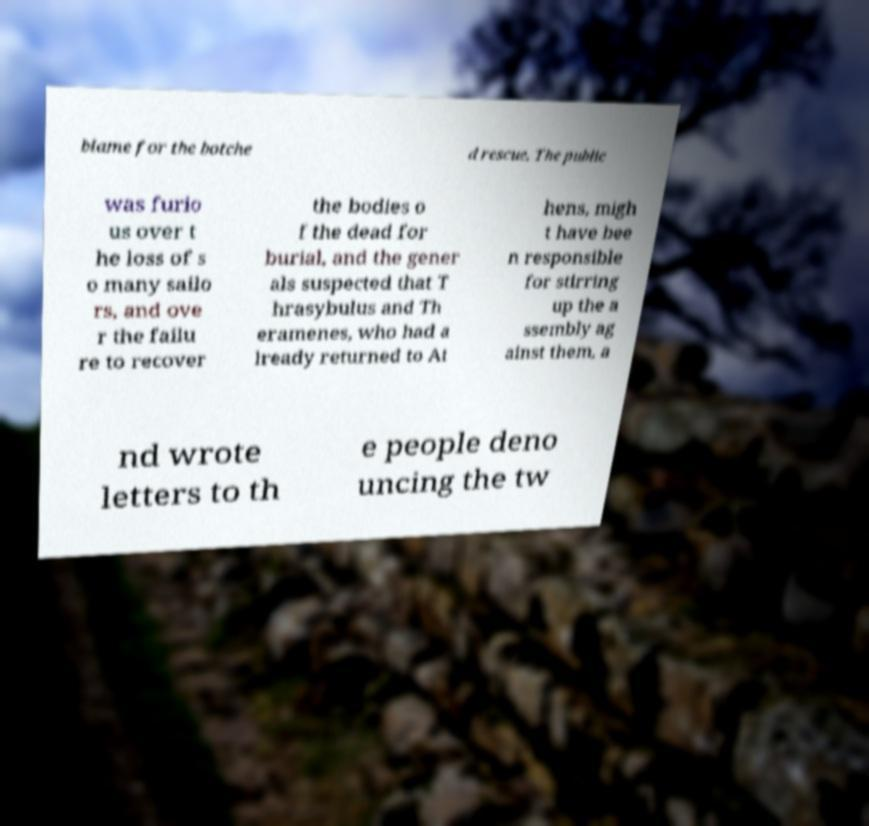There's text embedded in this image that I need extracted. Can you transcribe it verbatim? blame for the botche d rescue. The public was furio us over t he loss of s o many sailo rs, and ove r the failu re to recover the bodies o f the dead for burial, and the gener als suspected that T hrasybulus and Th eramenes, who had a lready returned to At hens, migh t have bee n responsible for stirring up the a ssembly ag ainst them, a nd wrote letters to th e people deno uncing the tw 